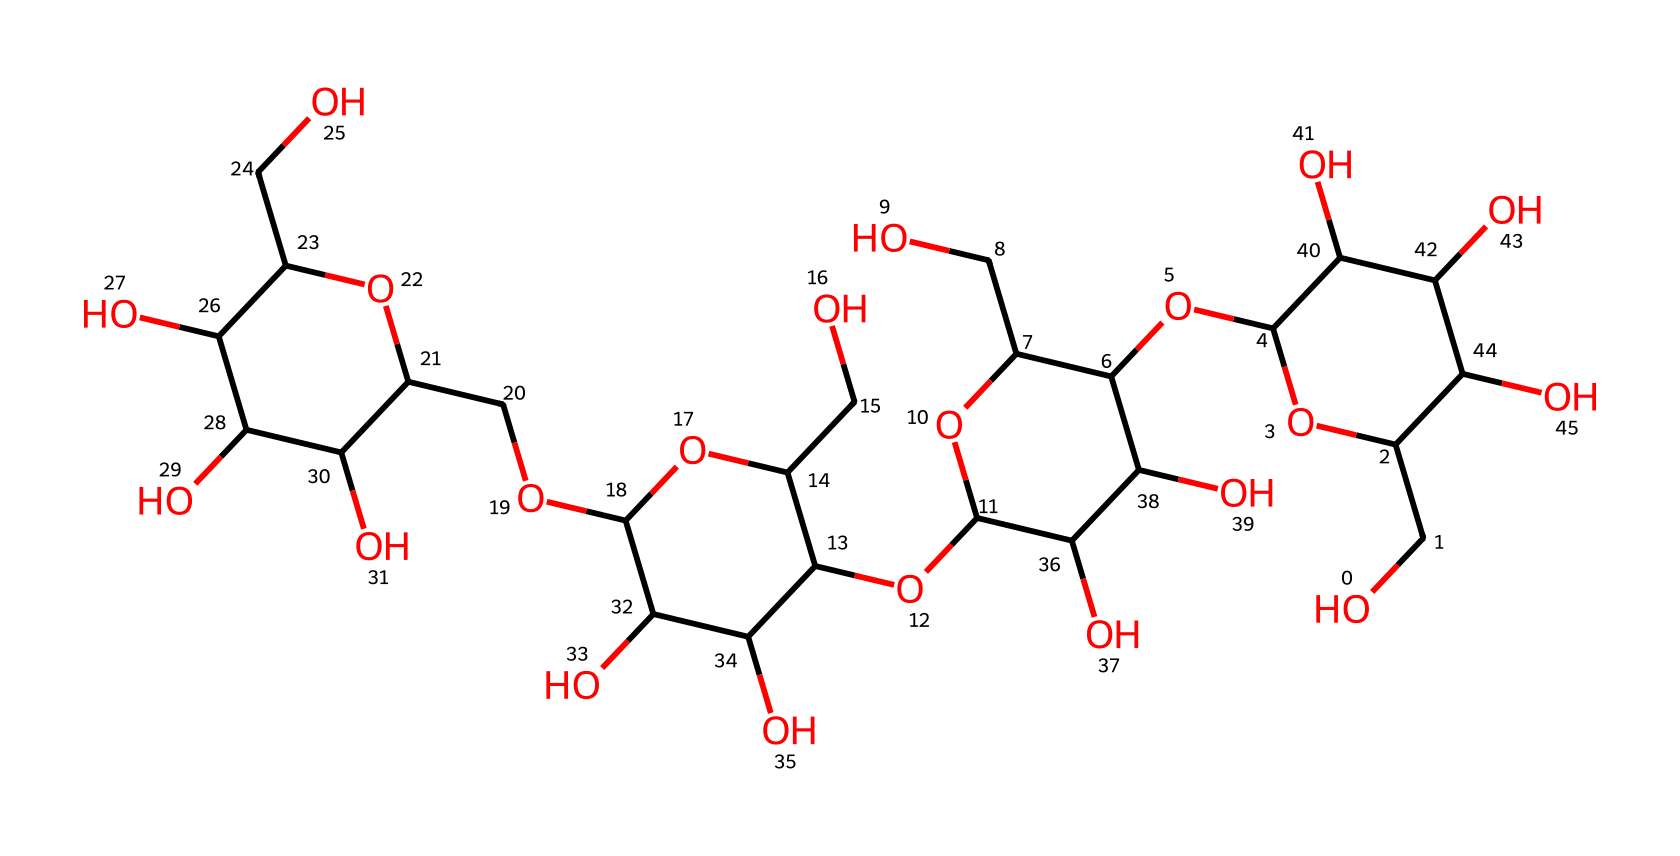How many carbon atoms are present in this chemical? By counting the number of carbon atoms in the provided SMILES representation, we identify that each 'C' denotes a carbon atom. There are several occurrences of 'C' in the structure, which sums up to a total of 30 carbon atoms.
Answer: 30 What type of carbohydrate is represented here? The complex structure of the SMILES code indicates it is a polysaccharide due to the presence of multiple glucose units linked together through glycosidic bonds. This is characteristic of starch, commonly found in cassava.
Answer: polysaccharide What is the degree of hydration in this carbohydrate structure? Looking at the chemical structure, for every glucose unit, there are water molecules associated as hydroxyl (-OH) groups and water, indicating that the structure is fully hydrated, typical for starches in biological systems.
Answer: fully hydrated How many rings are present in the carbohydrate structure? By analyzing the structure, we can identify that there are multiple cyclic forms (rings) of glucose present, which is common in polysaccharides. In this specific structure, there are 4 distinct rings formed by the glucose units.
Answer: 4 What type of bond connects the glucose units in this carbohydrate? The structure shows that the glucose units are linked via glycosidic bonds, which are formed by the condensation reaction between hydroxyl groups of adjacent glucose molecules. This is characteristic of starch.
Answer: glycosidic bond What functional groups are present in the structure? On examining the SMILES, we can find multiple hydroxyl (-OH) groups indicating the presence of alcohol functional groups along with a potential ether functional group due to the linkage of the glucose units. These groups give starch its hydrophilicity and solubility in water.
Answer: hydroxyl groups 